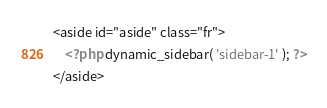Convert code to text. <code><loc_0><loc_0><loc_500><loc_500><_PHP_>
<aside id="aside" class="fr">
	<?php dynamic_sidebar( 'sidebar-1' ); ?>
</aside></code> 